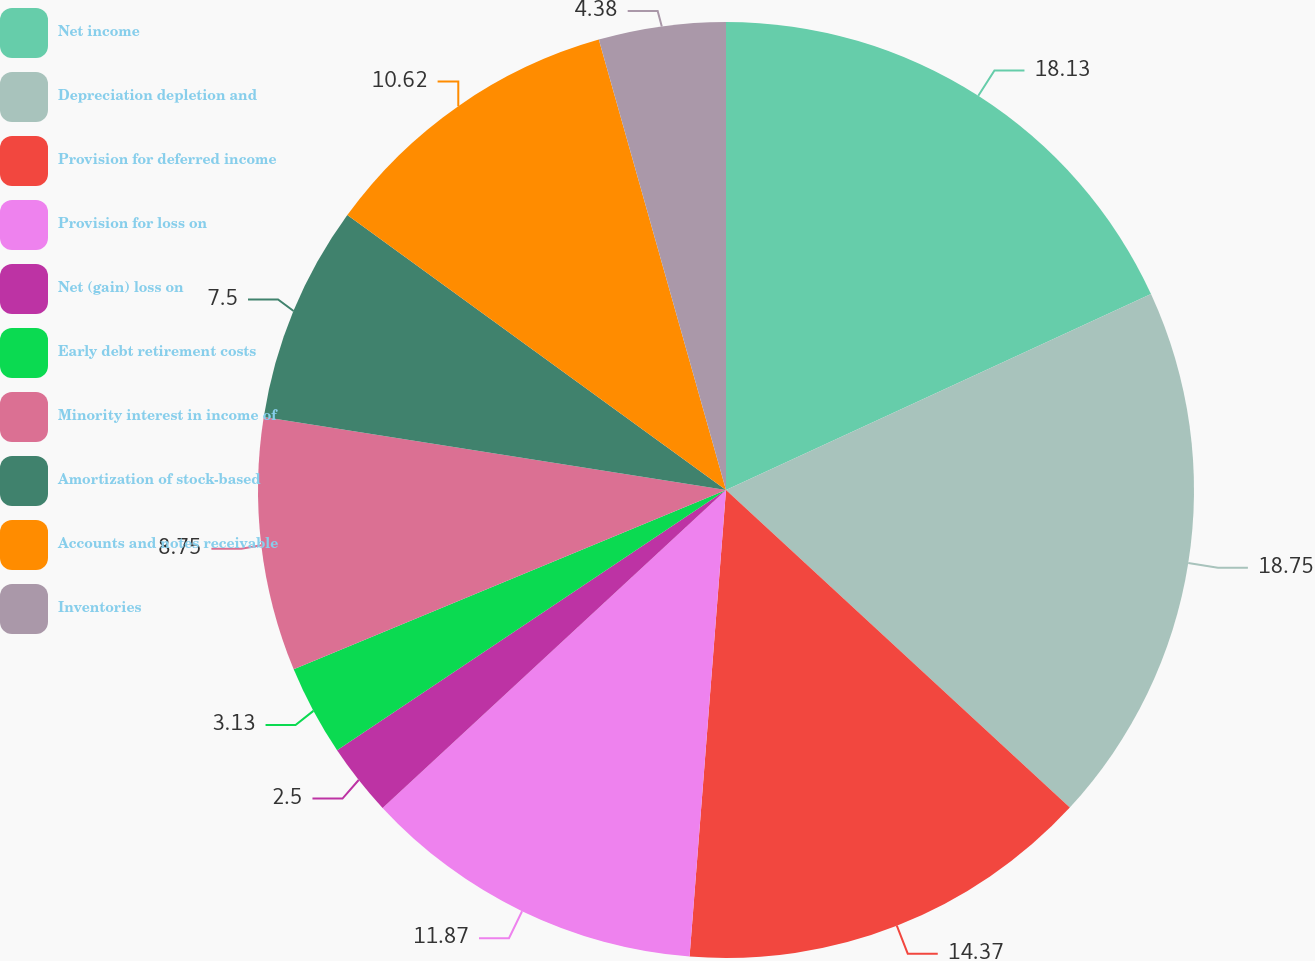<chart> <loc_0><loc_0><loc_500><loc_500><pie_chart><fcel>Net income<fcel>Depreciation depletion and<fcel>Provision for deferred income<fcel>Provision for loss on<fcel>Net (gain) loss on<fcel>Early debt retirement costs<fcel>Minority interest in income of<fcel>Amortization of stock-based<fcel>Accounts and notes receivable<fcel>Inventories<nl><fcel>18.12%<fcel>18.74%<fcel>14.37%<fcel>11.87%<fcel>2.5%<fcel>3.13%<fcel>8.75%<fcel>7.5%<fcel>10.62%<fcel>4.38%<nl></chart> 